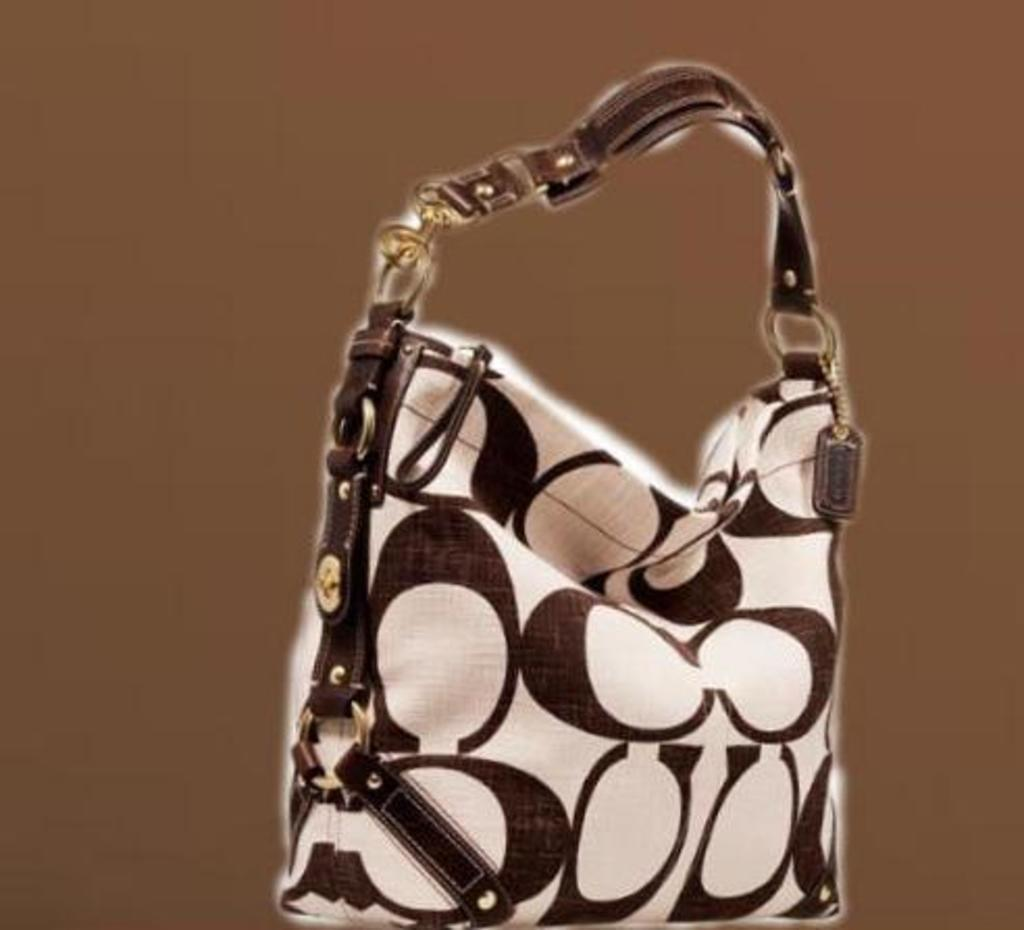What object can be seen in the image? There is a bag in the image. Can you describe the appearance of the bag? The bag is white and brown in color. How many pears are inside the bag in the image? There are no pears present in the image, and the bag's contents are not visible. 